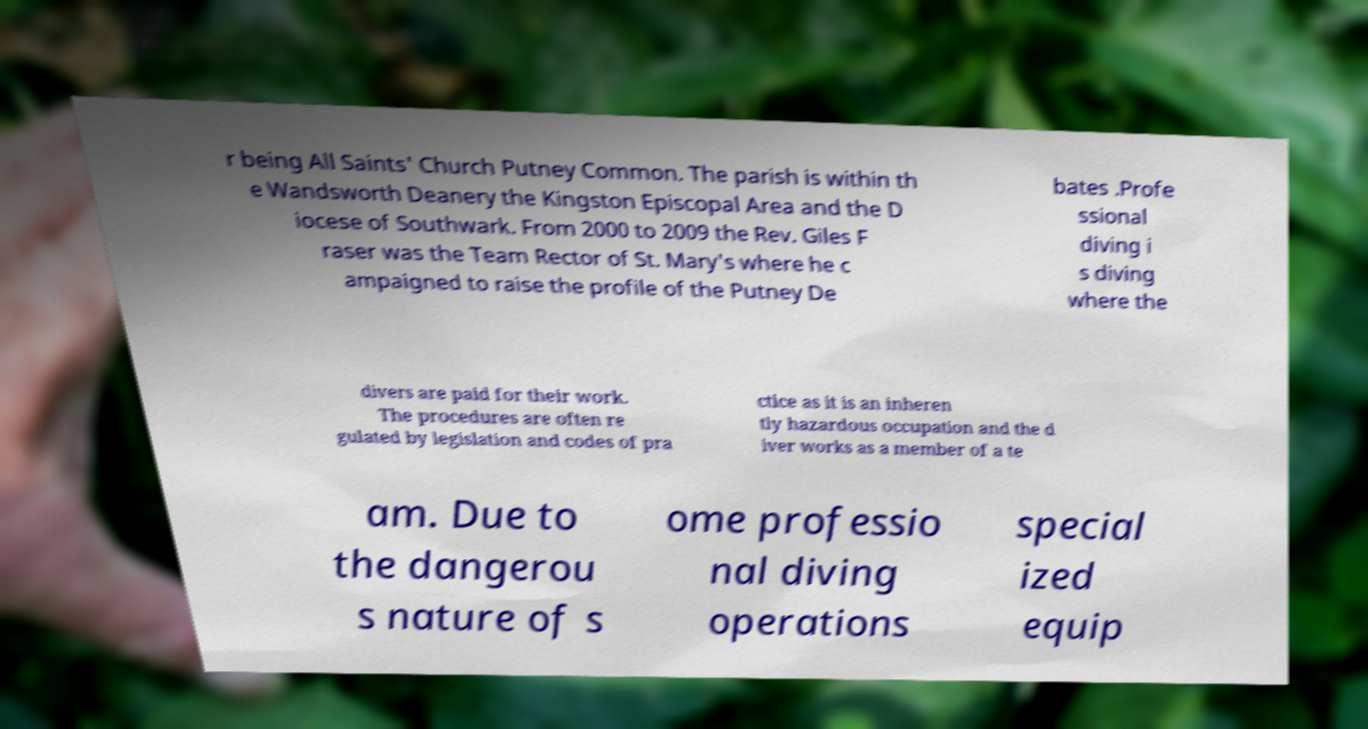Could you assist in decoding the text presented in this image and type it out clearly? r being All Saints' Church Putney Common. The parish is within th e Wandsworth Deanery the Kingston Episcopal Area and the D iocese of Southwark. From 2000 to 2009 the Rev. Giles F raser was the Team Rector of St. Mary's where he c ampaigned to raise the profile of the Putney De bates .Profe ssional diving i s diving where the divers are paid for their work. The procedures are often re gulated by legislation and codes of pra ctice as it is an inheren tly hazardous occupation and the d iver works as a member of a te am. Due to the dangerou s nature of s ome professio nal diving operations special ized equip 